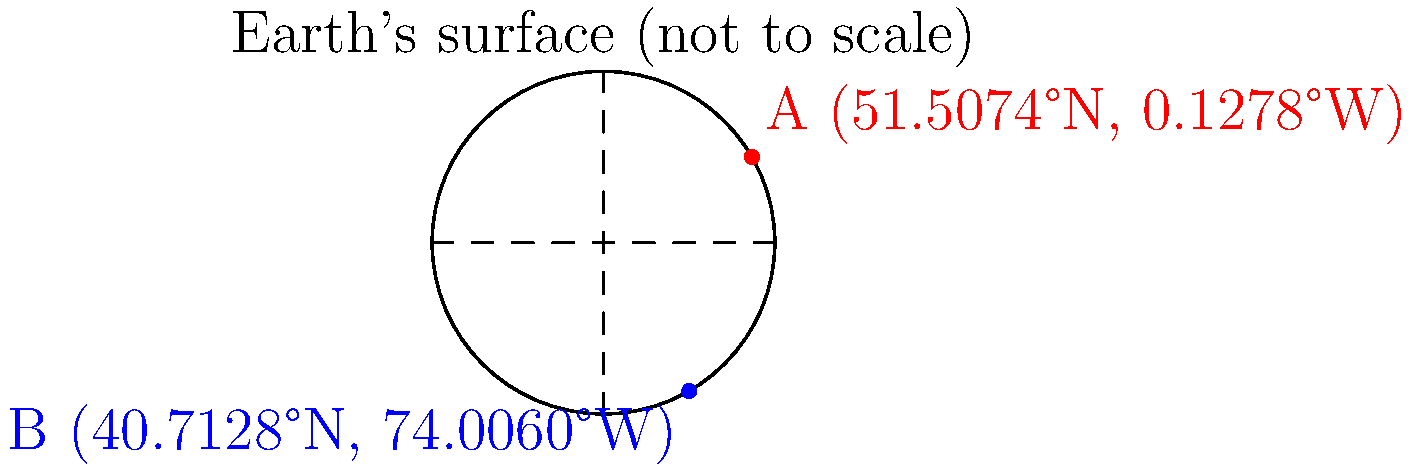As a Java developer who values clean code and best practices, you're tasked with implementing a method to calculate the distance between two points on Earth's surface using their latitude and longitude coordinates. Given point A (51.5074°N, 0.1278°W) in London and point B (40.7128°N, 74.0060°W) in New York City, calculate the great-circle distance between these two points using the Haversine formula. Assume the Earth's radius is 6371 km. Round your answer to the nearest kilometer. To solve this problem, we'll use the Haversine formula, which is particularly suitable for calculating great-circle distances on a sphere. Here's a step-by-step explanation:

1. Convert latitude and longitude from degrees to radians:
   $$\text{lat1} = 51.5074° \times \frac{\pi}{180} = 0.8990 \text{ rad}$$
   $$\text{lon1} = -0.1278° \times \frac{\pi}{180} = -0.0022 \text{ rad}$$
   $$\text{lat2} = 40.7128° \times \frac{\pi}{180} = 0.7104 \text{ rad}$$
   $$\text{lon2} = -74.0060° \times \frac{\pi}{180} = -1.2917 \text{ rad}$$

2. Calculate the differences in latitude and longitude:
   $$\Delta\text{lat} = \text{lat2} - \text{lat1} = -0.1886 \text{ rad}$$
   $$\Delta\text{lon} = \text{lon2} - \text{lon1} = -1.2895 \text{ rad}$$

3. Apply the Haversine formula:
   $$a = \sin^2(\frac{\Delta\text{lat}}{2}) + \cos(\text{lat1}) \times \cos(\text{lat2}) \times \sin^2(\frac{\Delta\text{lon}}{2})$$
   $$c = 2 \times \arctan2(\sqrt{a}, \sqrt{1-a})$$
   $$d = R \times c$$

   Where $R$ is the Earth's radius (6371 km).

4. Calculate the result:
   $$a = \sin^2(-0.0943) + \cos(0.8990) \times \cos(0.7104) \times \sin^2(-0.6447) = 0.1974$$
   $$c = 2 \times \arctan2(\sqrt{0.1974}, \sqrt{1-0.1974}) = 0.9044$$
   $$d = 6371 \times 0.9044 = 5762.7 \text{ km}$$

5. Round to the nearest kilometer:
   $$d \approx 5763 \text{ km}$$

In Java, you would implement this calculation in a method, ensuring to use `Math.toRadians()` for degree-to-radian conversion and `Math.sin()`, `Math.cos()`, `Math.sqrt()`, and `Math.atan2()` for the trigonometric calculations. Remember to use descriptive variable names and add appropriate comments for better code readability and maintainability.
Answer: 5763 km 